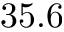<formula> <loc_0><loc_0><loc_500><loc_500>3 5 . 6</formula> 